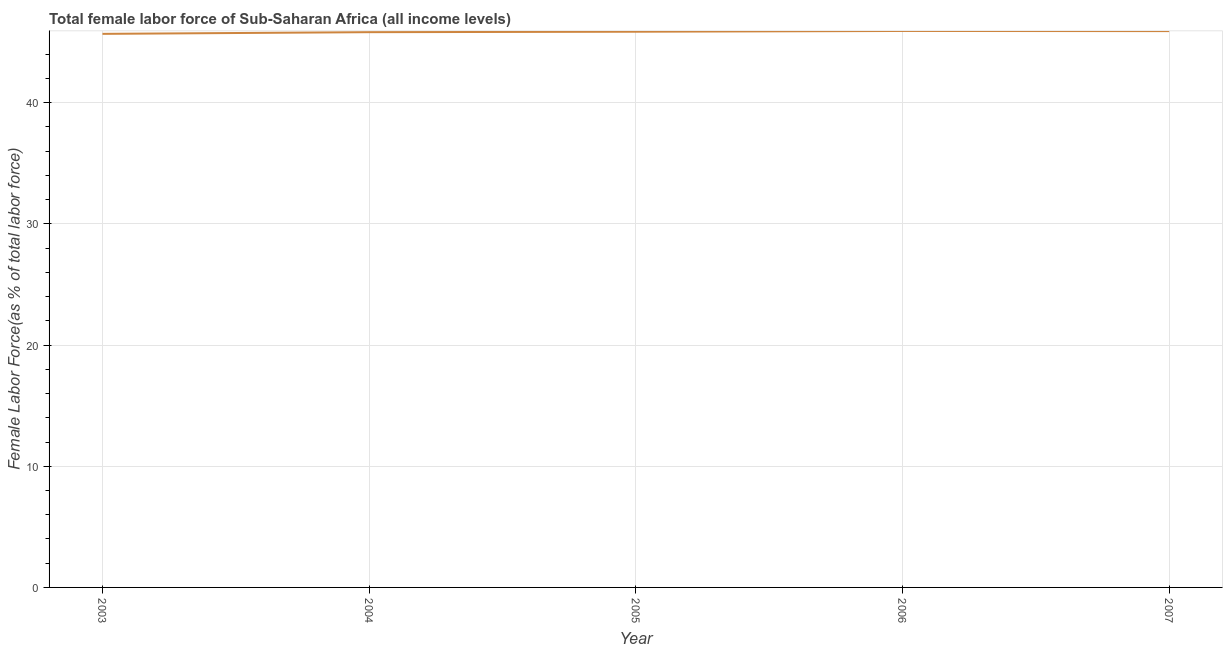What is the total female labor force in 2003?
Provide a succinct answer. 45.68. Across all years, what is the maximum total female labor force?
Provide a succinct answer. 45.92. Across all years, what is the minimum total female labor force?
Give a very brief answer. 45.68. In which year was the total female labor force minimum?
Provide a short and direct response. 2003. What is the sum of the total female labor force?
Offer a very short reply. 229.19. What is the difference between the total female labor force in 2006 and 2007?
Ensure brevity in your answer.  0.01. What is the average total female labor force per year?
Your answer should be very brief. 45.84. What is the median total female labor force?
Your answer should be compact. 45.86. What is the ratio of the total female labor force in 2004 to that in 2007?
Keep it short and to the point. 1. Is the total female labor force in 2003 less than that in 2004?
Make the answer very short. Yes. What is the difference between the highest and the second highest total female labor force?
Offer a very short reply. 0.01. What is the difference between the highest and the lowest total female labor force?
Offer a terse response. 0.24. In how many years, is the total female labor force greater than the average total female labor force taken over all years?
Keep it short and to the point. 3. Does the total female labor force monotonically increase over the years?
Offer a very short reply. No. What is the difference between two consecutive major ticks on the Y-axis?
Your answer should be very brief. 10. Does the graph contain any zero values?
Offer a terse response. No. What is the title of the graph?
Keep it short and to the point. Total female labor force of Sub-Saharan Africa (all income levels). What is the label or title of the X-axis?
Offer a very short reply. Year. What is the label or title of the Y-axis?
Your response must be concise. Female Labor Force(as % of total labor force). What is the Female Labor Force(as % of total labor force) of 2003?
Ensure brevity in your answer.  45.68. What is the Female Labor Force(as % of total labor force) in 2004?
Offer a terse response. 45.82. What is the Female Labor Force(as % of total labor force) in 2005?
Offer a very short reply. 45.86. What is the Female Labor Force(as % of total labor force) in 2006?
Your answer should be compact. 45.92. What is the Female Labor Force(as % of total labor force) in 2007?
Keep it short and to the point. 45.91. What is the difference between the Female Labor Force(as % of total labor force) in 2003 and 2004?
Make the answer very short. -0.14. What is the difference between the Female Labor Force(as % of total labor force) in 2003 and 2005?
Offer a terse response. -0.18. What is the difference between the Female Labor Force(as % of total labor force) in 2003 and 2006?
Make the answer very short. -0.24. What is the difference between the Female Labor Force(as % of total labor force) in 2003 and 2007?
Your answer should be very brief. -0.23. What is the difference between the Female Labor Force(as % of total labor force) in 2004 and 2005?
Ensure brevity in your answer.  -0.04. What is the difference between the Female Labor Force(as % of total labor force) in 2004 and 2006?
Make the answer very short. -0.1. What is the difference between the Female Labor Force(as % of total labor force) in 2004 and 2007?
Offer a very short reply. -0.09. What is the difference between the Female Labor Force(as % of total labor force) in 2005 and 2006?
Ensure brevity in your answer.  -0.06. What is the difference between the Female Labor Force(as % of total labor force) in 2005 and 2007?
Give a very brief answer. -0.05. What is the difference between the Female Labor Force(as % of total labor force) in 2006 and 2007?
Offer a very short reply. 0.01. What is the ratio of the Female Labor Force(as % of total labor force) in 2003 to that in 2005?
Give a very brief answer. 1. What is the ratio of the Female Labor Force(as % of total labor force) in 2004 to that in 2007?
Make the answer very short. 1. What is the ratio of the Female Labor Force(as % of total labor force) in 2005 to that in 2007?
Make the answer very short. 1. 